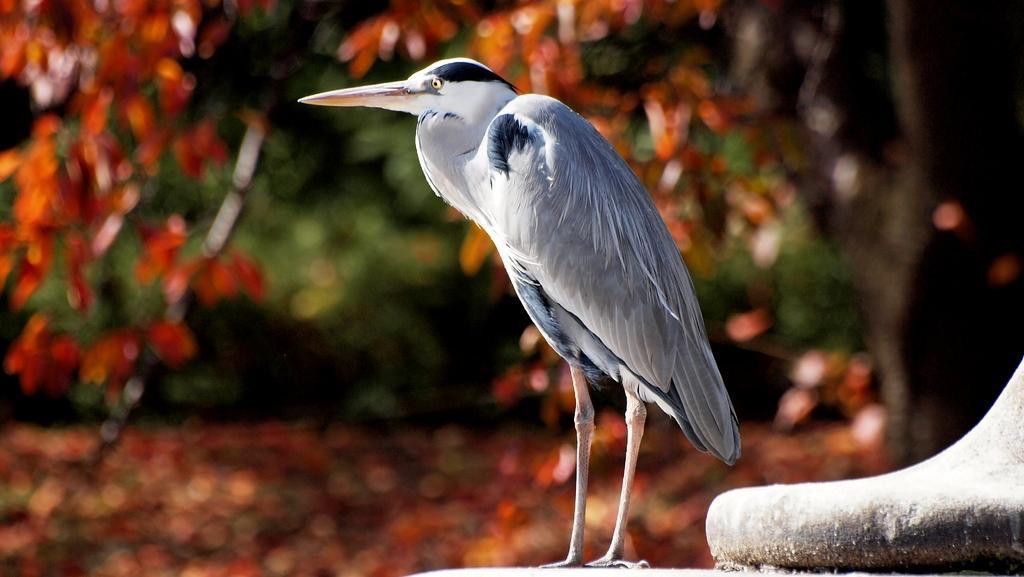Describe this image in one or two sentences. As we can see in the image in the front there is a white color bird. In the background there are trees and the background is little blurred. 